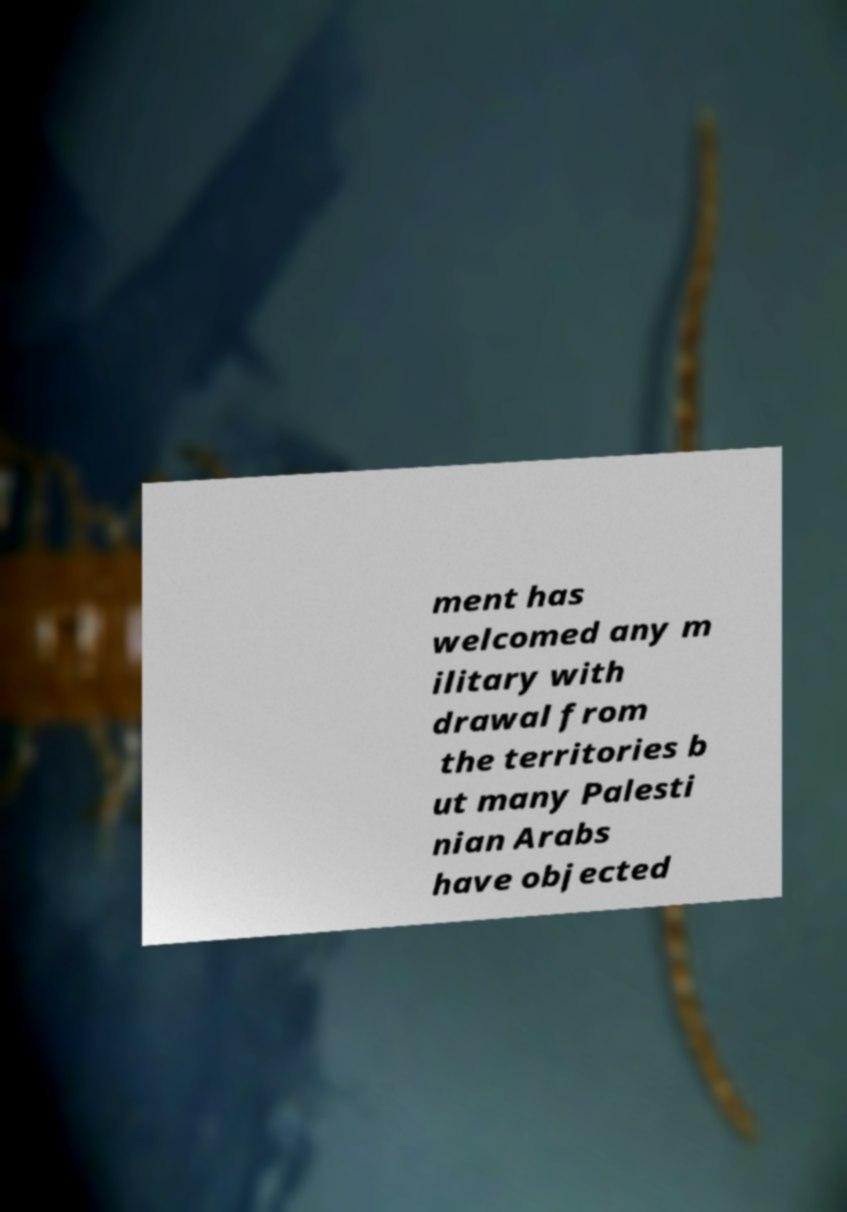I need the written content from this picture converted into text. Can you do that? ment has welcomed any m ilitary with drawal from the territories b ut many Palesti nian Arabs have objected 